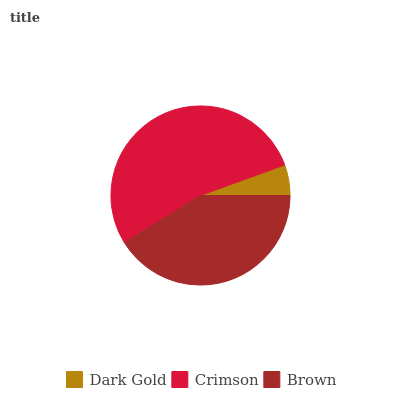Is Dark Gold the minimum?
Answer yes or no. Yes. Is Crimson the maximum?
Answer yes or no. Yes. Is Brown the minimum?
Answer yes or no. No. Is Brown the maximum?
Answer yes or no. No. Is Crimson greater than Brown?
Answer yes or no. Yes. Is Brown less than Crimson?
Answer yes or no. Yes. Is Brown greater than Crimson?
Answer yes or no. No. Is Crimson less than Brown?
Answer yes or no. No. Is Brown the high median?
Answer yes or no. Yes. Is Brown the low median?
Answer yes or no. Yes. Is Crimson the high median?
Answer yes or no. No. Is Dark Gold the low median?
Answer yes or no. No. 